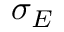Convert formula to latex. <formula><loc_0><loc_0><loc_500><loc_500>\sigma _ { E }</formula> 